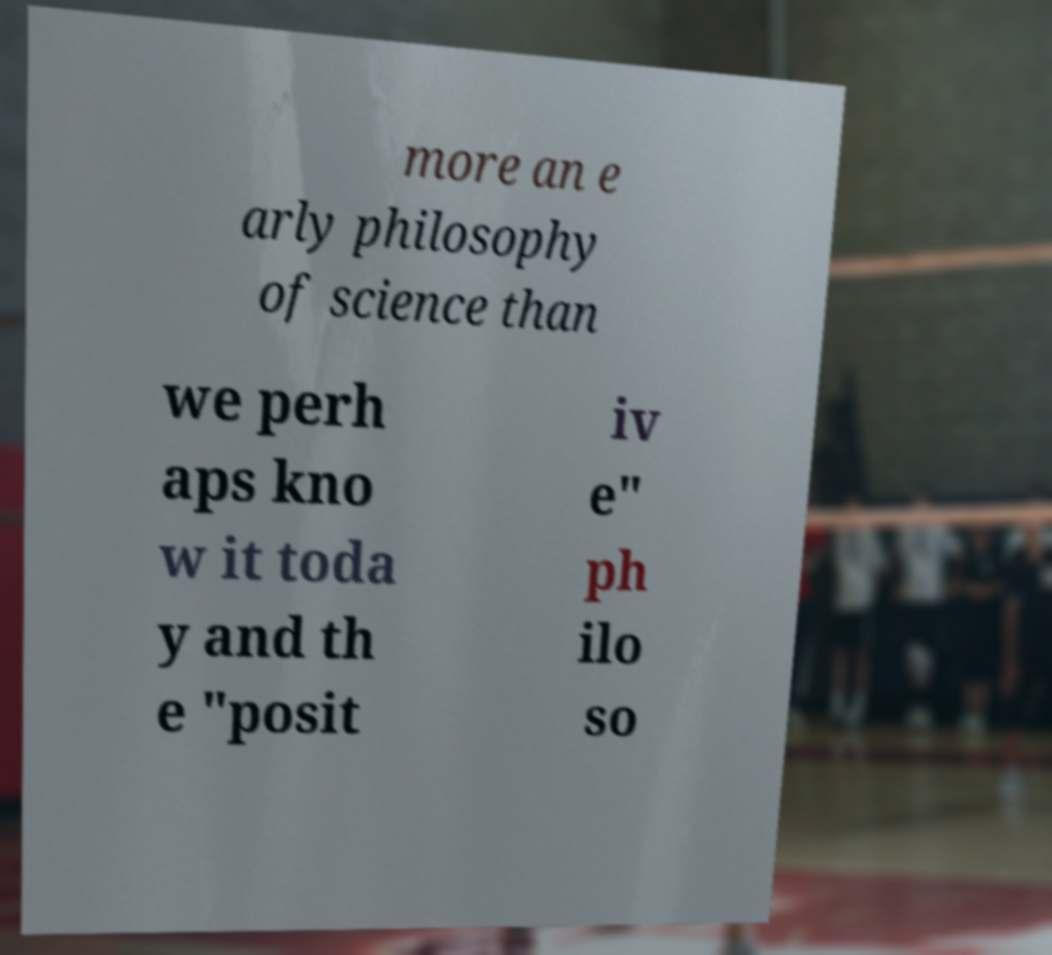Please read and relay the text visible in this image. What does it say? more an e arly philosophy of science than we perh aps kno w it toda y and th e "posit iv e" ph ilo so 